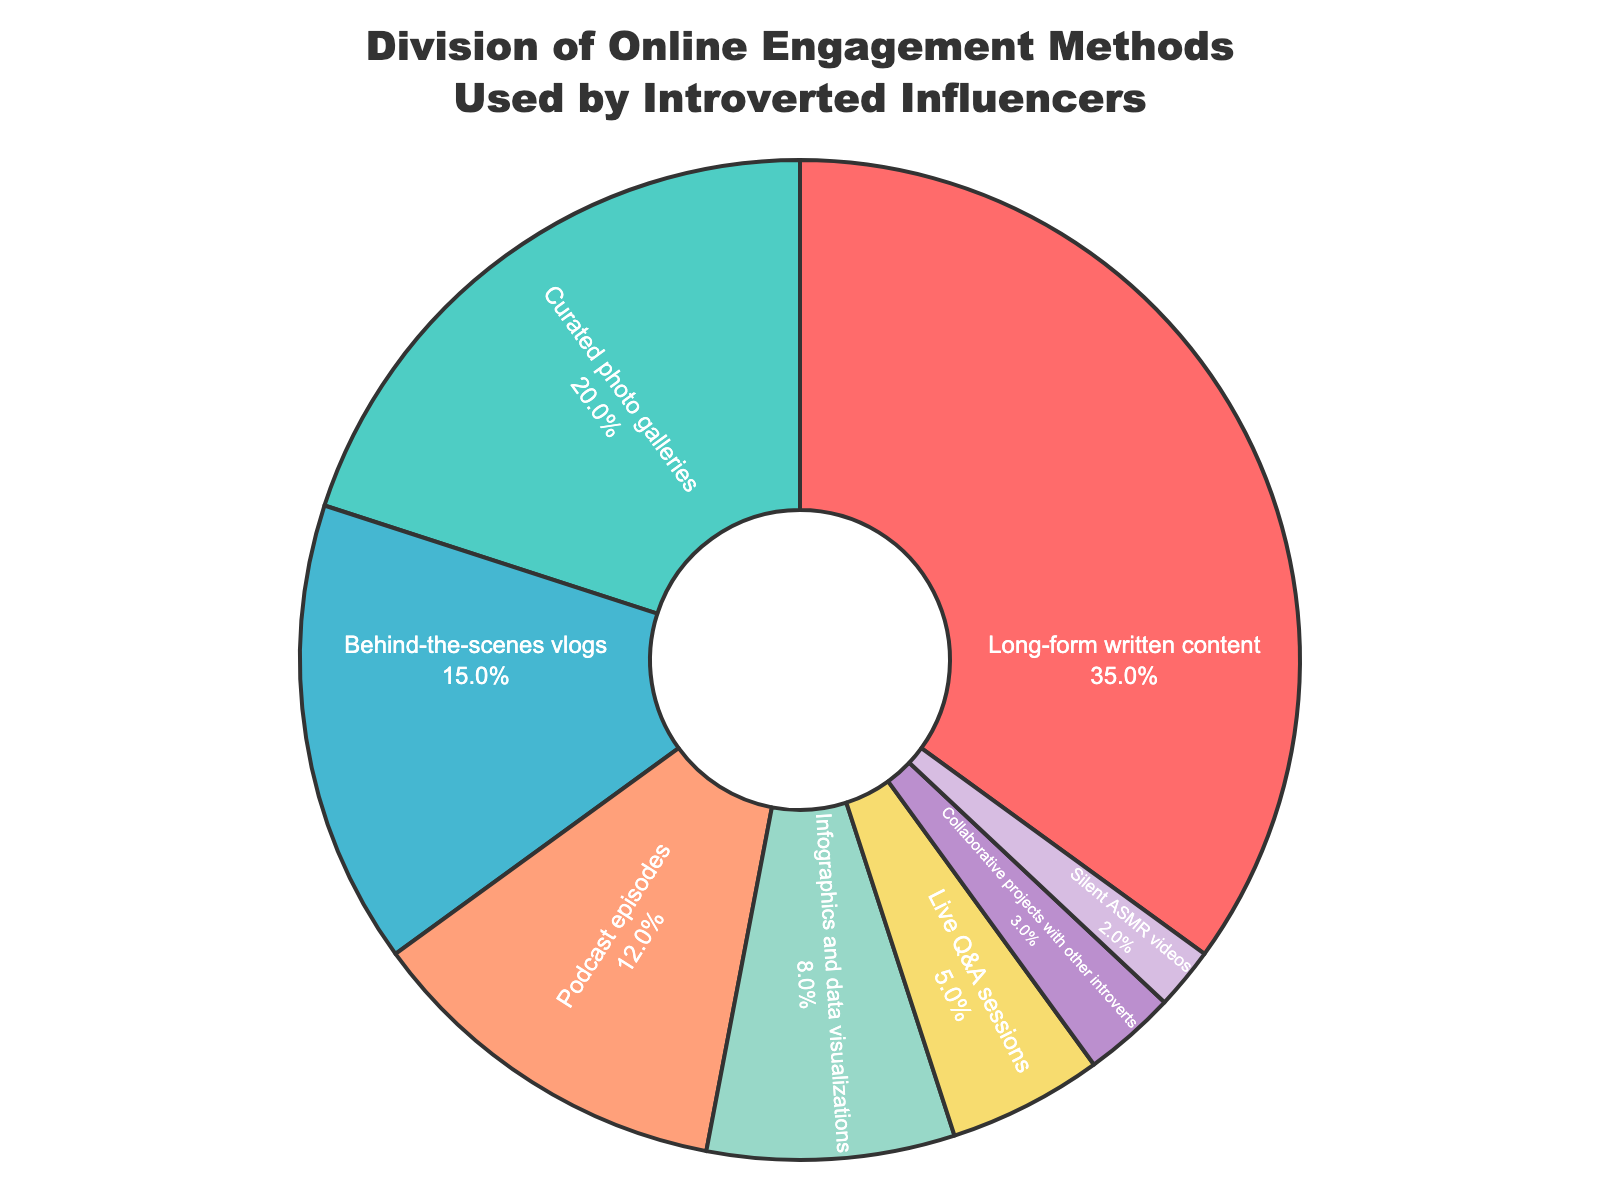Which engagement method has the largest percentage? We are looking for the slice of the pie chart with the largest value represented as a percentage. Observing the chart, "Long-form written content" has 35%.
Answer: Long-form written content What is the combined percentage of curated photo galleries and behind-the-scenes vlogs? Add the percentages of "Curated photo galleries" (20%) and "Behind-the-scenes vlogs" (15%) together to get the combined total. 20% + 15% = 35%
Answer: 35% Which method is used more, podcast episodes or infographics and data visualizations? Compare the percentages. Podcast episodes have 12%, while infographics and data visualizations have 8%. Since 12% is greater than 8%, podcast episodes are used more.
Answer: Podcast episodes How much higher is the percentage of long-form written content compared to live Q&A sessions? Subtract the percentage of live Q&A sessions (5%) from long-form written content (35%). 35% - 5% = 30%
Answer: 30% Which engagement methods collectively account for less than 10% of the engagement? From the chart, we observe that Collaborative projects with other introverts (3%) and Silent ASMR videos (2%) are the only categories under 10%. Adding them: 3% + 2% = 5%.
Answer: Collaborative projects with other introverts, Silent ASMR videos What is the average percentage of the top three engagement methods? The top three methods are "Long-form written content" (35%), "Curated photo galleries" (20%), and "Behind-the-scenes vlogs" (15%). Calculate the average: (35% + 20% + 15%) / 3 = 23.33%
Answer: 23.33% Which engagement method uses the purple slice in the pie chart? The purple slice corresponds to "Collaborative projects with other introverts," which is 3% of the pie chart.
Answer: Collaborative projects with other introverts Are live Q&A sessions used more than silent ASMR videos? By how much? Live Q&A sessions have 5% while Silent ASMR videos have 2%. Subtract 2% from 5% to find the difference. 5% - 2% = 3%.
Answer: Yes, by 3% What is the combined percentage of engagement methods that are used less than infographics and data visualizations? Methods less than 8% (Infographics and data visualizations) are Collaborative projects with other introverts (3%) and Silent ASMR videos (2%). Add them: 3% + 2% = 5%
Answer: 5% 